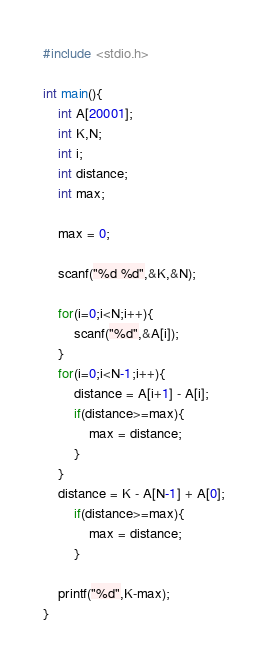<code> <loc_0><loc_0><loc_500><loc_500><_C_>#include <stdio.h>

int main(){
    int A[20001];
    int K,N;
    int i;
    int distance;
    int max;

    max = 0;

    scanf("%d %d",&K,&N);

    for(i=0;i<N;i++){
        scanf("%d",&A[i]);
    }
    for(i=0;i<N-1;i++){
        distance = A[i+1] - A[i];
        if(distance>=max){
            max = distance;
        }
    }
    distance = K - A[N-1] + A[0];
        if(distance>=max){
            max = distance;
        }

    printf("%d",K-max);
}


</code> 